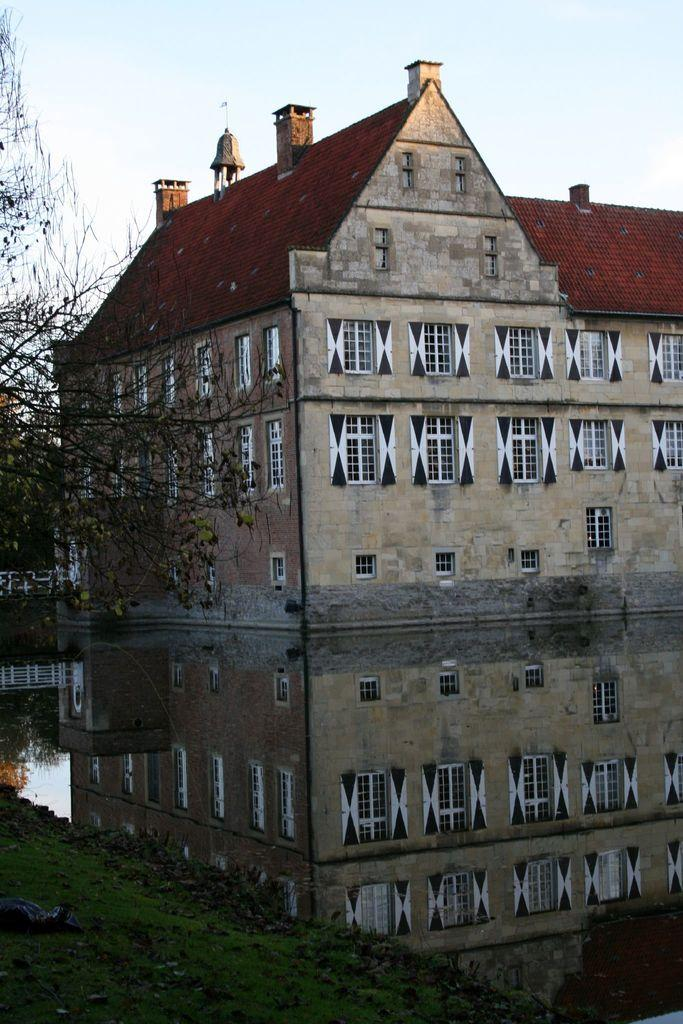What type of vegetation is at the bottom of the image? There is grass at the bottom of the image. What can be seen on the left side of the image? There is a tree on the left side of the image. What structure is located in the middle of the image? There is a building in the middle of the image. What is present alongside the building in the middle of the image? There is water in the middle of the image. What is visible at the top of the image? The sky is visible at the top of the image. What type of wheel is visible in the image? There is no wheel present in the image. What religious symbol can be seen in the image? There is no religious symbol present in the image. 